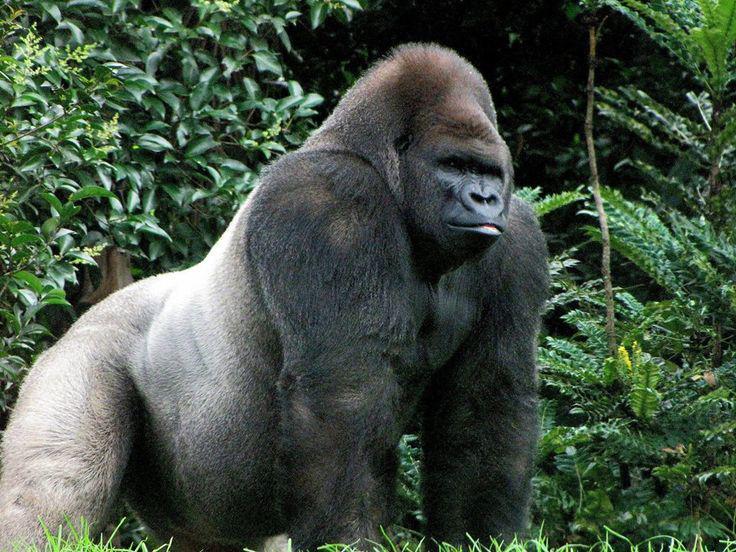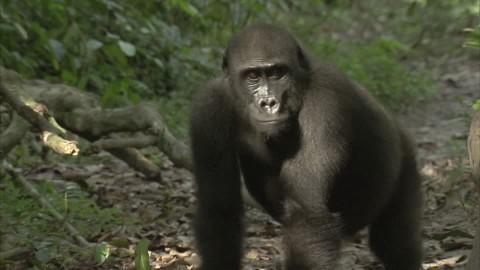The first image is the image on the left, the second image is the image on the right. Considering the images on both sides, is "There is visible sky in one of the images." valid? Answer yes or no. No. 